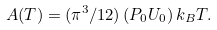Convert formula to latex. <formula><loc_0><loc_0><loc_500><loc_500>A ( T ) = ( \pi ^ { 3 } / 1 2 ) \, ( P _ { 0 } U _ { 0 } ) \, k _ { B } T .</formula> 